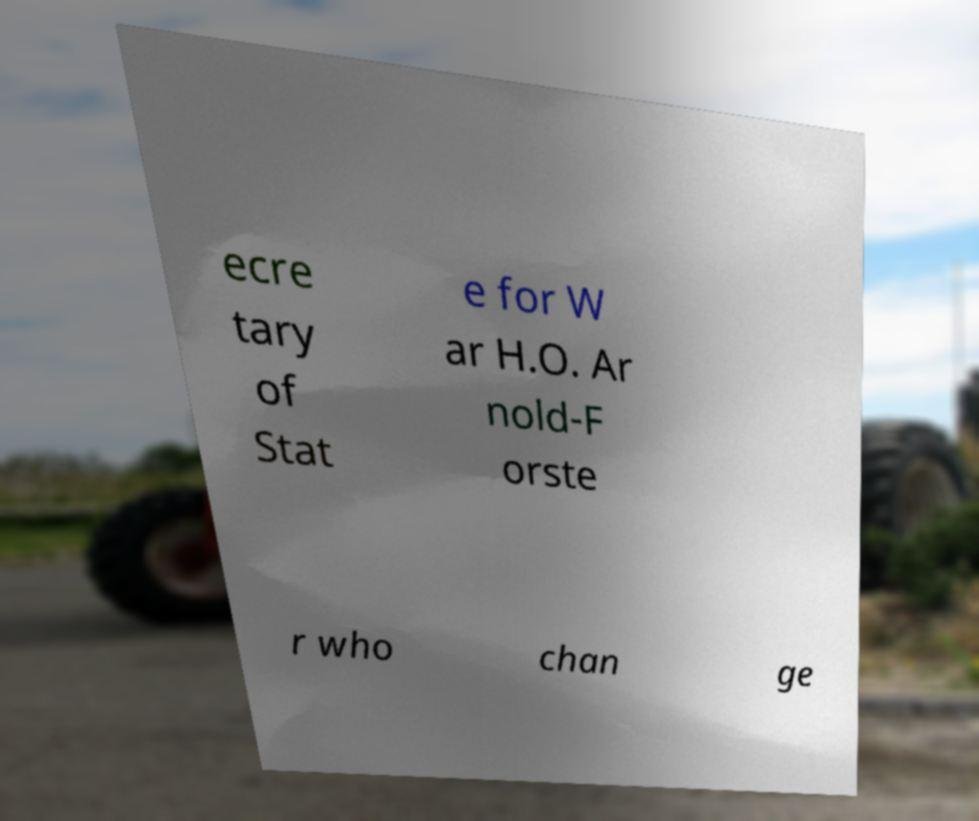Could you assist in decoding the text presented in this image and type it out clearly? ecre tary of Stat e for W ar H.O. Ar nold-F orste r who chan ge 